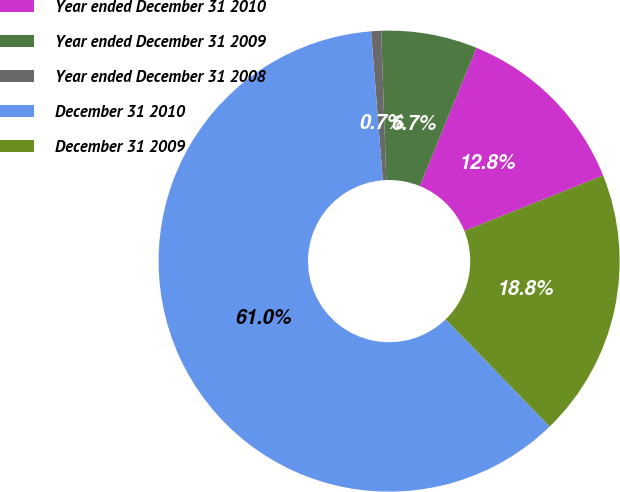Convert chart to OTSL. <chart><loc_0><loc_0><loc_500><loc_500><pie_chart><fcel>Year ended December 31 2010<fcel>Year ended December 31 2009<fcel>Year ended December 31 2008<fcel>December 31 2010<fcel>December 31 2009<nl><fcel>12.76%<fcel>6.73%<fcel>0.7%<fcel>61.01%<fcel>18.79%<nl></chart> 